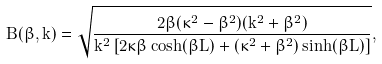Convert formula to latex. <formula><loc_0><loc_0><loc_500><loc_500>B ( \beta , k ) = \sqrt { \frac { 2 \beta ( \kappa ^ { 2 } - \beta ^ { 2 } ) ( k ^ { 2 } + \beta ^ { 2 } ) } { k ^ { 2 } \left [ 2 \kappa \beta \cosh ( \beta L ) + ( \kappa ^ { 2 } + \beta ^ { 2 } ) \sinh ( \beta L ) \right ] } } ,</formula> 